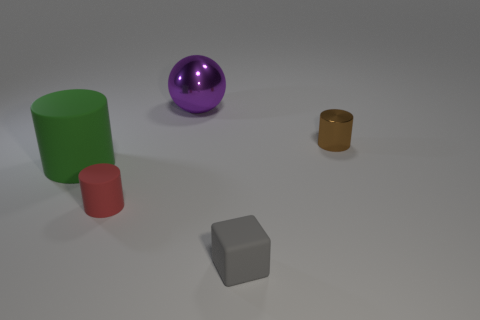Subtract all small brown metal cylinders. How many cylinders are left? 2 Add 2 large blue rubber spheres. How many objects exist? 7 Subtract 1 blocks. How many blocks are left? 0 Add 4 big red shiny cylinders. How many big red shiny cylinders exist? 4 Subtract all red cylinders. How many cylinders are left? 2 Subtract 0 gray balls. How many objects are left? 5 Subtract all spheres. How many objects are left? 4 Subtract all red balls. Subtract all yellow cylinders. How many balls are left? 1 Subtract all yellow rubber things. Subtract all small gray objects. How many objects are left? 4 Add 4 green cylinders. How many green cylinders are left? 5 